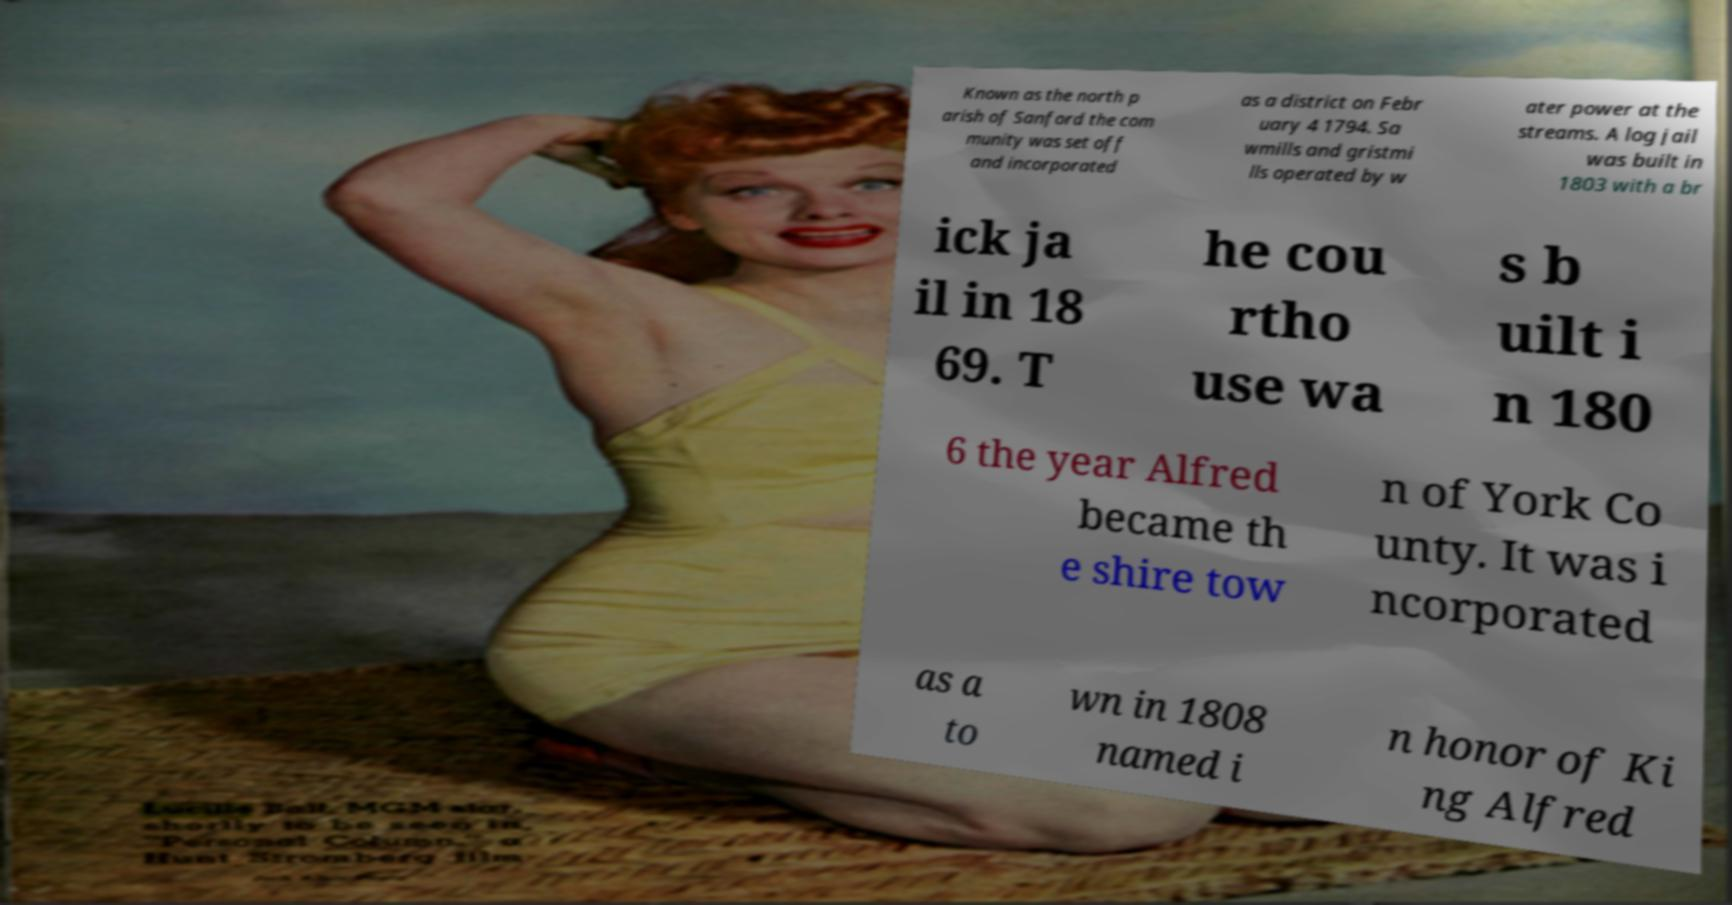For documentation purposes, I need the text within this image transcribed. Could you provide that? Known as the north p arish of Sanford the com munity was set off and incorporated as a district on Febr uary 4 1794. Sa wmills and gristmi lls operated by w ater power at the streams. A log jail was built in 1803 with a br ick ja il in 18 69. T he cou rtho use wa s b uilt i n 180 6 the year Alfred became th e shire tow n of York Co unty. It was i ncorporated as a to wn in 1808 named i n honor of Ki ng Alfred 